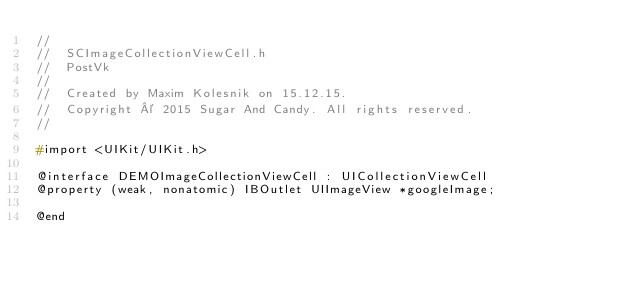Convert code to text. <code><loc_0><loc_0><loc_500><loc_500><_C_>//
//  SCImageCollectionViewCell.h
//  PostVk
//
//  Created by Maxim Kolesnik on 15.12.15.
//  Copyright © 2015 Sugar And Candy. All rights reserved.
//

#import <UIKit/UIKit.h>

@interface DEMOImageCollectionViewCell : UICollectionViewCell
@property (weak, nonatomic) IBOutlet UIImageView *googleImage;

@end
</code> 